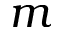Convert formula to latex. <formula><loc_0><loc_0><loc_500><loc_500>m</formula> 